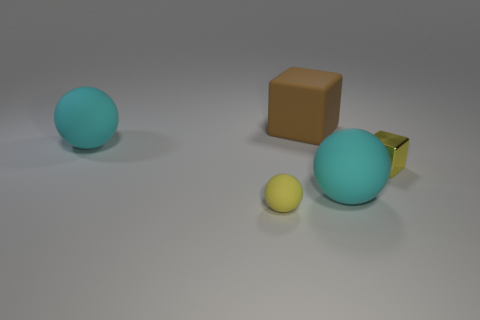What is the relative position of the blue ball to the brown cube? The large blue ball is situated to the left and slightly behind the brown cube from the perspective of the viewer. Is the surface they are on reflective, and can you see any shadows? The surface appears to be matte, showing very subtle light reflections. Each object casts a soft shadow on the surface, indicating a light source from above. 